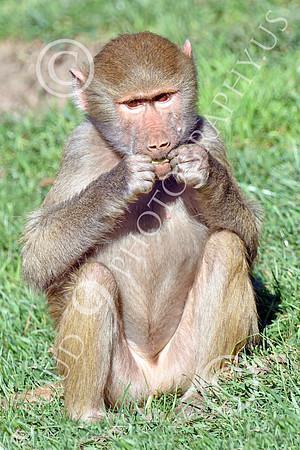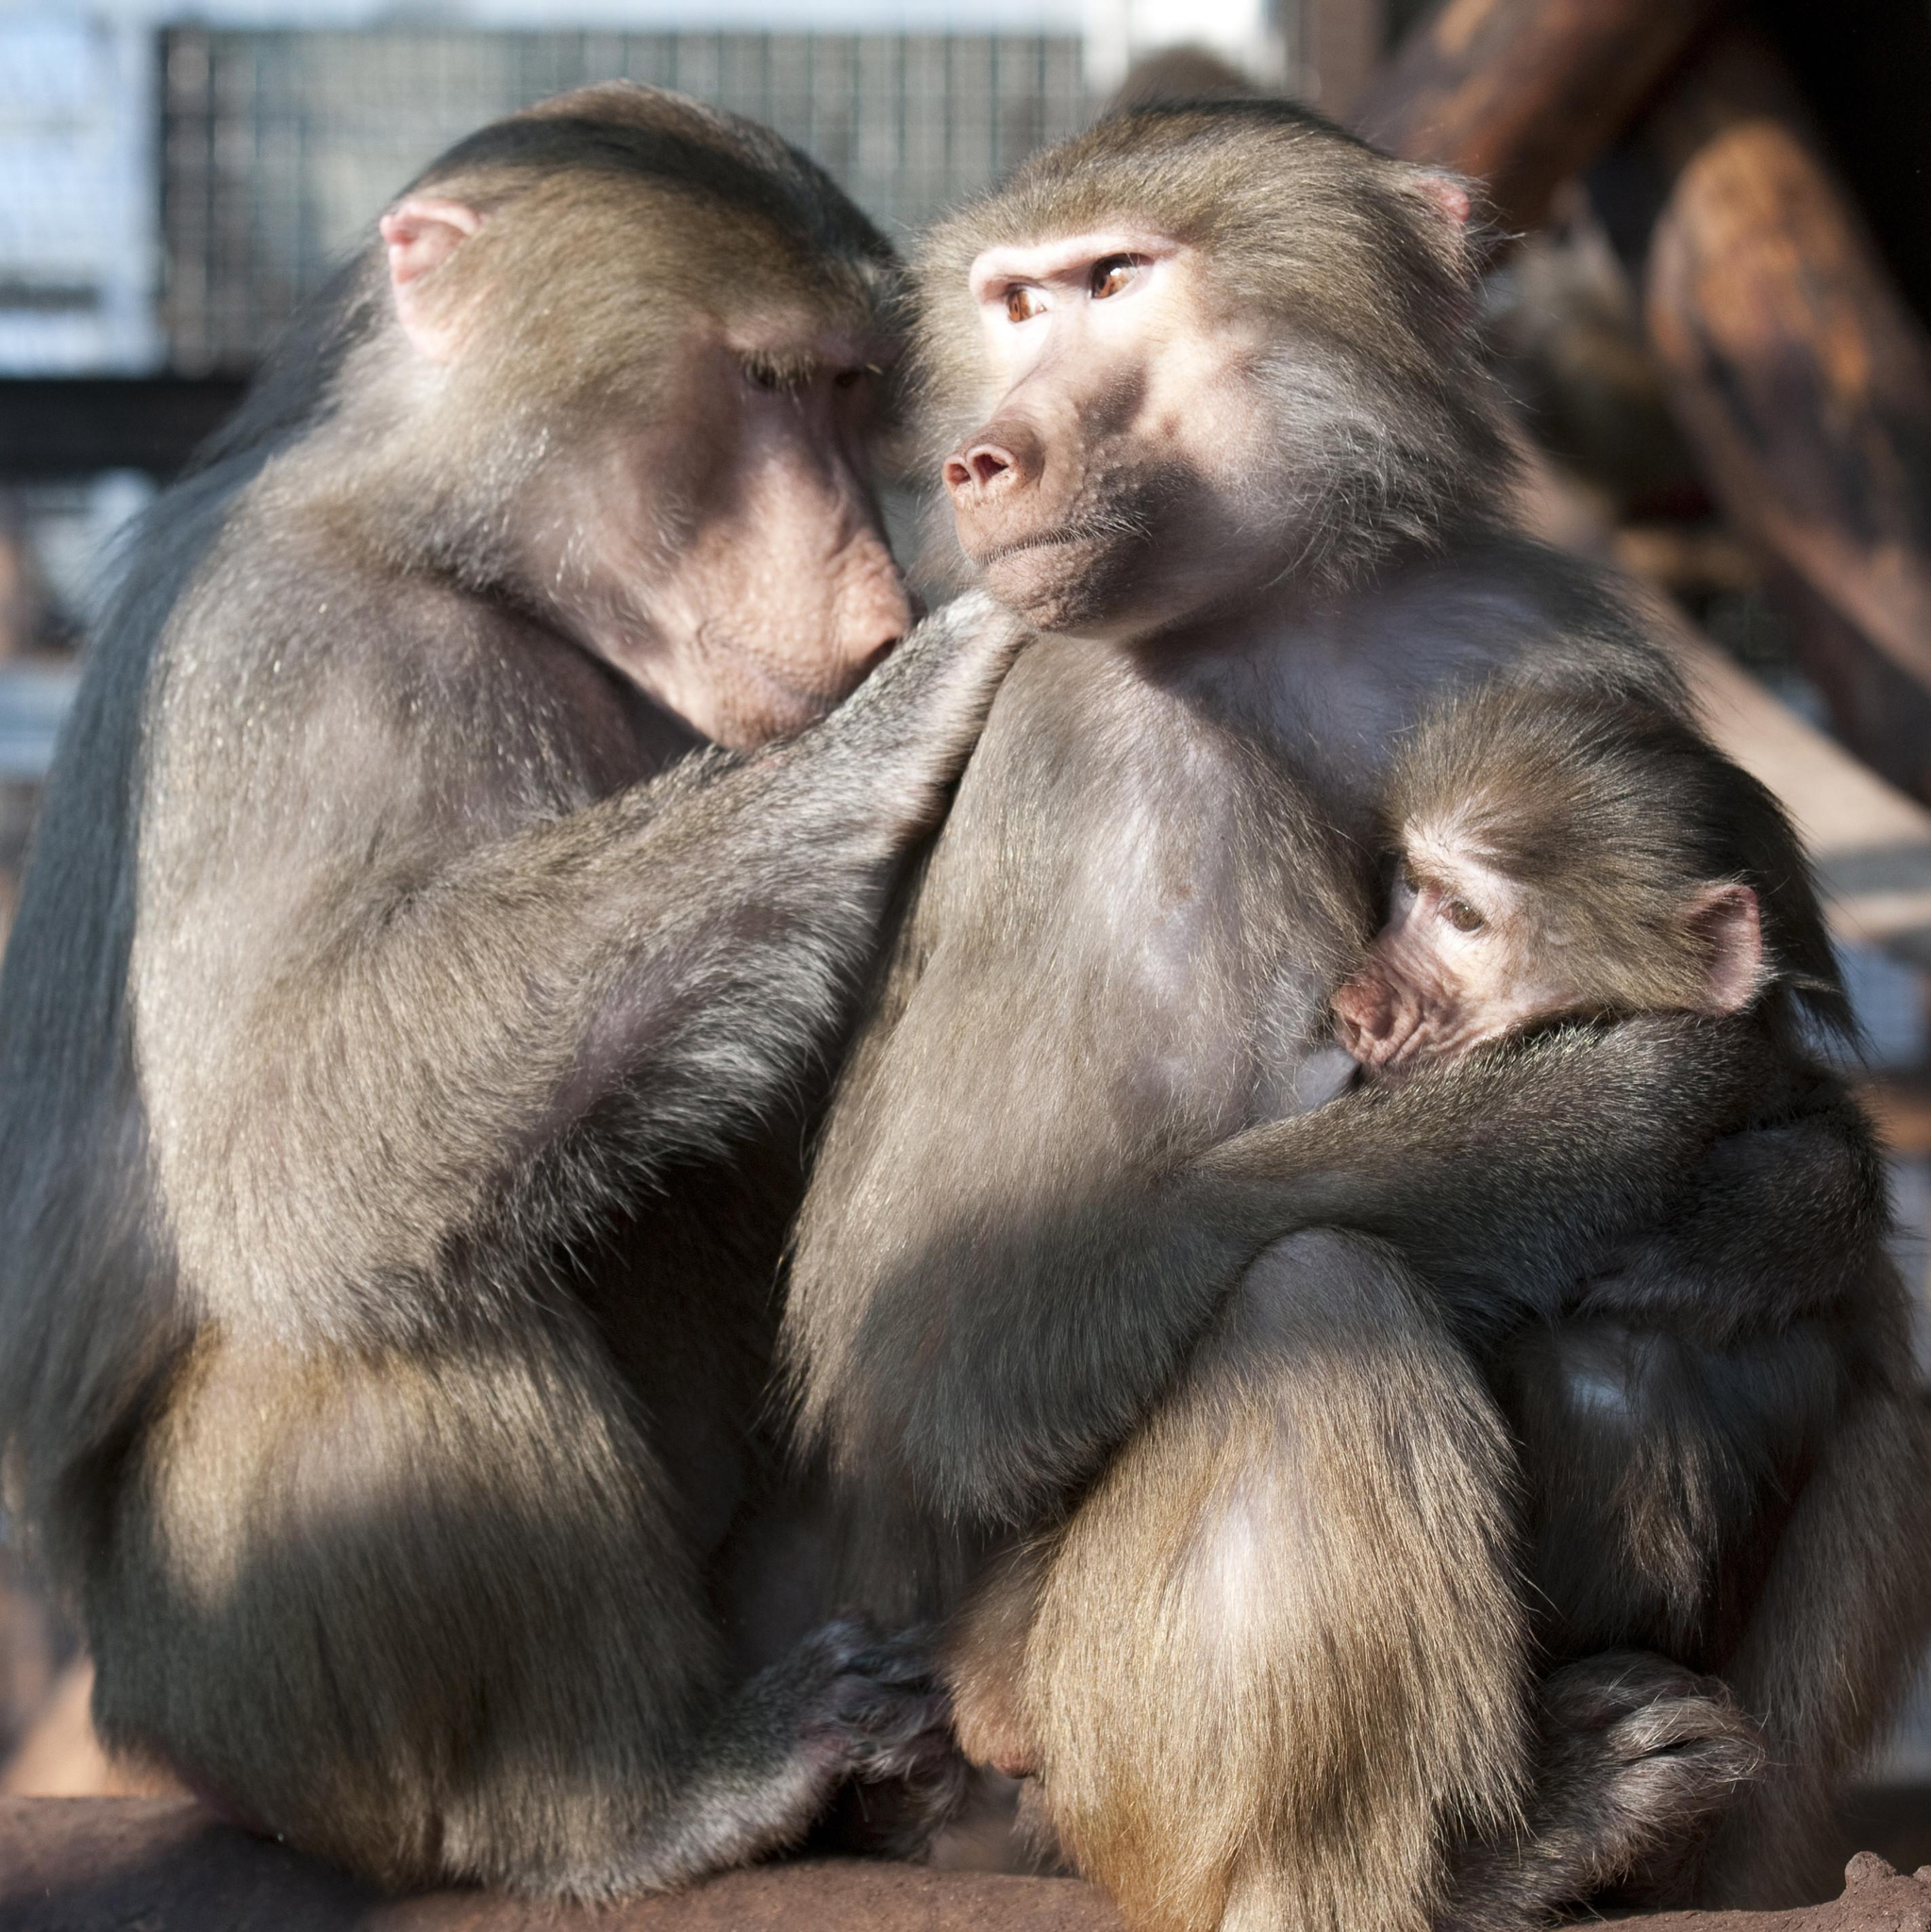The first image is the image on the left, the second image is the image on the right. Assess this claim about the two images: "One image shows at least three baboons posed close together, and the other image shows one forward-facing baboon sitting with bent knees.". Correct or not? Answer yes or no. Yes. The first image is the image on the left, the second image is the image on the right. Evaluate the accuracy of this statement regarding the images: "The monkey in the right image is eating something.". Is it true? Answer yes or no. No. 